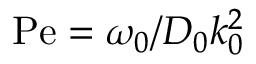<formula> <loc_0><loc_0><loc_500><loc_500>P e = \omega _ { 0 } / D _ { 0 } k _ { 0 } ^ { 2 }</formula> 